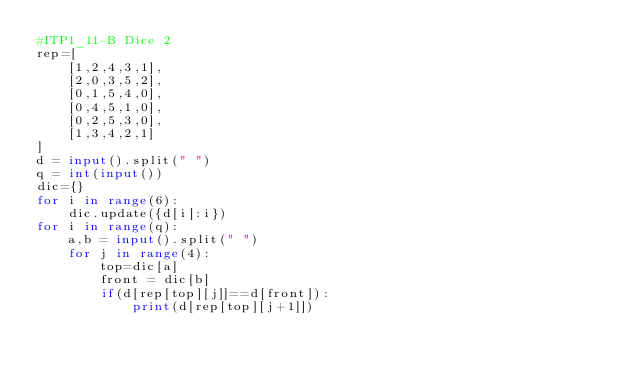Convert code to text. <code><loc_0><loc_0><loc_500><loc_500><_Python_>#ITP1_11-B Dice 2
rep=[
    [1,2,4,3,1],
    [2,0,3,5,2],
    [0,1,5,4,0],
    [0,4,5,1,0],
    [0,2,5,3,0],
    [1,3,4,2,1]
]
d = input().split(" ")
q = int(input())
dic={}
for i in range(6):
    dic.update({d[i]:i})
for i in range(q):
    a,b = input().split(" ")
    for j in range(4):
        top=dic[a]
        front = dic[b]
        if(d[rep[top][j]]==d[front]):
            print(d[rep[top][j+1]])</code> 